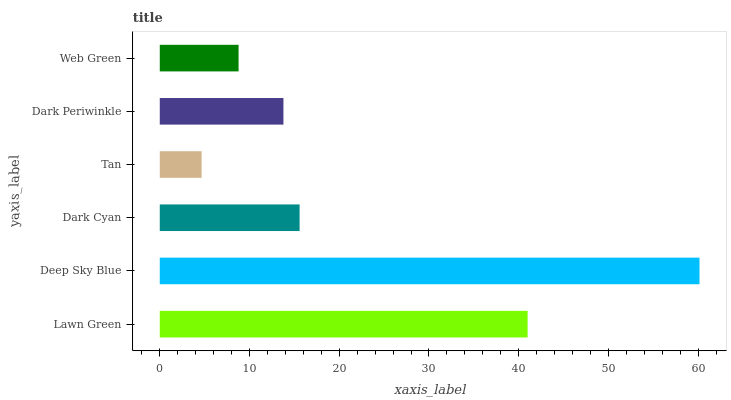Is Tan the minimum?
Answer yes or no. Yes. Is Deep Sky Blue the maximum?
Answer yes or no. Yes. Is Dark Cyan the minimum?
Answer yes or no. No. Is Dark Cyan the maximum?
Answer yes or no. No. Is Deep Sky Blue greater than Dark Cyan?
Answer yes or no. Yes. Is Dark Cyan less than Deep Sky Blue?
Answer yes or no. Yes. Is Dark Cyan greater than Deep Sky Blue?
Answer yes or no. No. Is Deep Sky Blue less than Dark Cyan?
Answer yes or no. No. Is Dark Cyan the high median?
Answer yes or no. Yes. Is Dark Periwinkle the low median?
Answer yes or no. Yes. Is Deep Sky Blue the high median?
Answer yes or no. No. Is Web Green the low median?
Answer yes or no. No. 